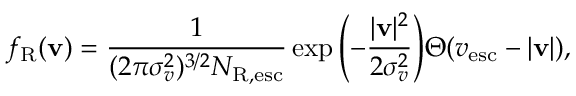Convert formula to latex. <formula><loc_0><loc_0><loc_500><loc_500>f _ { R } ( v ) = \frac { 1 } { ( 2 \pi \sigma _ { v } ^ { 2 } ) ^ { 3 / 2 } N _ { R , e s c } } \exp { \left ( - \frac { | v | ^ { 2 } } { 2 \sigma _ { v } ^ { 2 } } \right ) } \Theta ( v _ { e s c } - | v | ) ,</formula> 